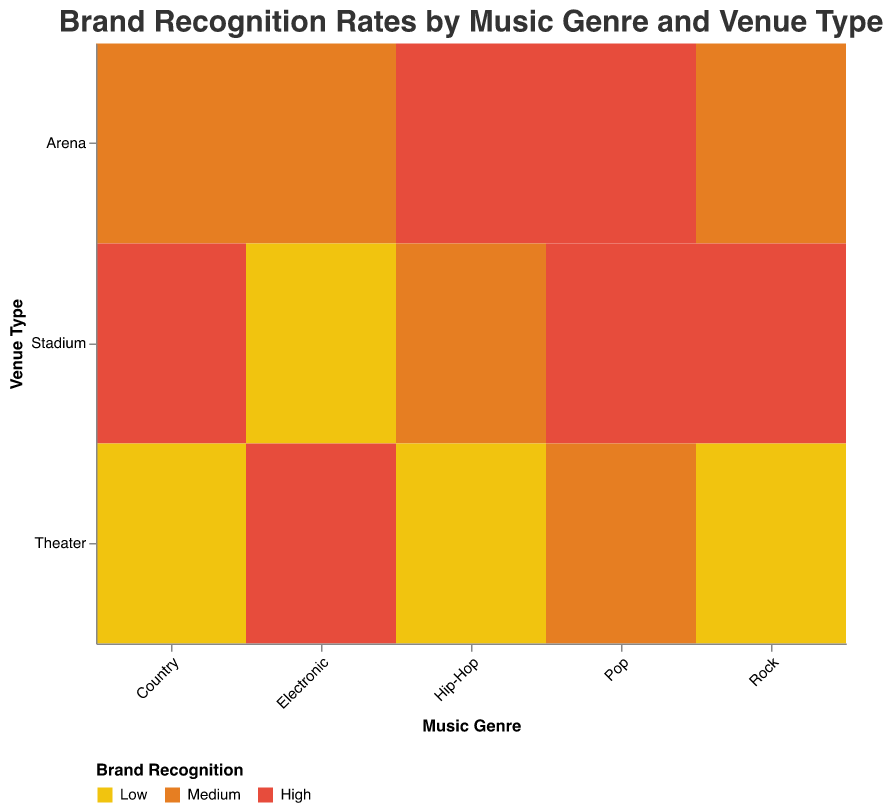What is the title of the plot? The title is placed at the top of the figure and provides an overview of what the plot is about. By reading it, you can understand the main theme of the data.
Answer: Brand Recognition Rates by Music Genre and Venue Type How are the recognition rates categorized in the plot? The plot uses colors to represent different recognition rates. The colors are specified in the legend at the bottom, with red, orange, and yellow representing 'High', 'Medium', and 'Low', respectively.
Answer: High, Medium, Low Which music genre and venue type combination has the highest brand recognition rate? To determine this, look at the blocks colored in red, which represent a high brand recognition rate, located at the intersections of Music Genre and Venue Type. Multiple blocks might qualify.
Answer: Pop and Arena, Pop and Stadium, Rock and Stadium, Hip-Hop and Arena, Country and Stadium For which music genre does the brand recognition rate differ the most across different venue types? Observe the color transitions across different venue types for each music genre. Calculate the variation from High to Low between venue types to identify the genre with the highest disparity.
Answer: Rock and Electronic Which venue type shows the highest overall brand recognition rates across all music genres? Check the venues that have the most red color blocks (High recognition) across different genres. Compare the occurrences among Arena, Stadium, and Theater.
Answer: Stadium How does the brand recognition rate for Pop differ between Arenas and Theaters? Look at the Pop row and compare the colors for Arena and Theater columns. Red indicates High for Arena and orange indicates Medium for Theater.
Answer: Pop in Arenas has a higher recognition rate than in Theaters What is the brand recognition rate for Hip-Hop in Theaters? Locate the intersection of Hip-Hop and Theater on the plot and observe the color. Yellow color indicates a Low recognition rate.
Answer: Low Compare the brand recognition rates for Electronic music in Stadiums and Theaters. From the plot, retrieve the color information for Electronic in both Stadiums and Theaters. Stadium has yellow (Low) and Theater has red (High).
Answer: Theaters have a higher recognition rate than Stadiums Which music genre has a consistent brand recognition rate across all venue types? Look for a music genre that shows uniform colors across all venue types, meaning no variation in the recognition rate.
Answer: None Does the Theater venue type have the highest recognition rate for any music genre? Examine the Theater column and identify if there's any red color block representing High recognition for any of the music genres.
Answer: Yes, for Electronic 